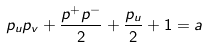Convert formula to latex. <formula><loc_0><loc_0><loc_500><loc_500>p _ { u } p _ { v } + \frac { p ^ { + } p ^ { - } } { 2 } + \frac { p _ { u } } { 2 } + 1 = a</formula> 